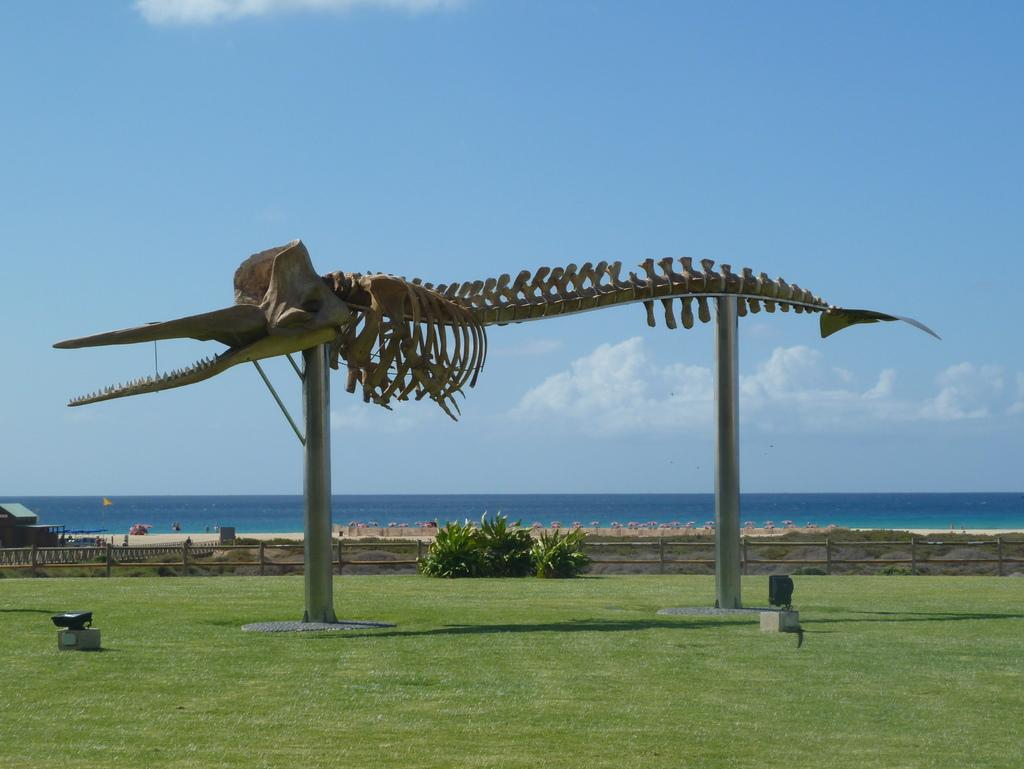What type of sea animal is depicted in the image? The image contains a skeleton of a sea animal. What other elements can be seen in the image besides the sea animal skeleton? There are plants, a house, the sea, and the sky visible in the image. Can you describe the plants in the image? The plants in the image are not specified, but they are visible. What type of rice is being cooked in the image? There is no rice present in the image; it features a skeleton of a sea animal, plants, a house, the sea, and the sky. 